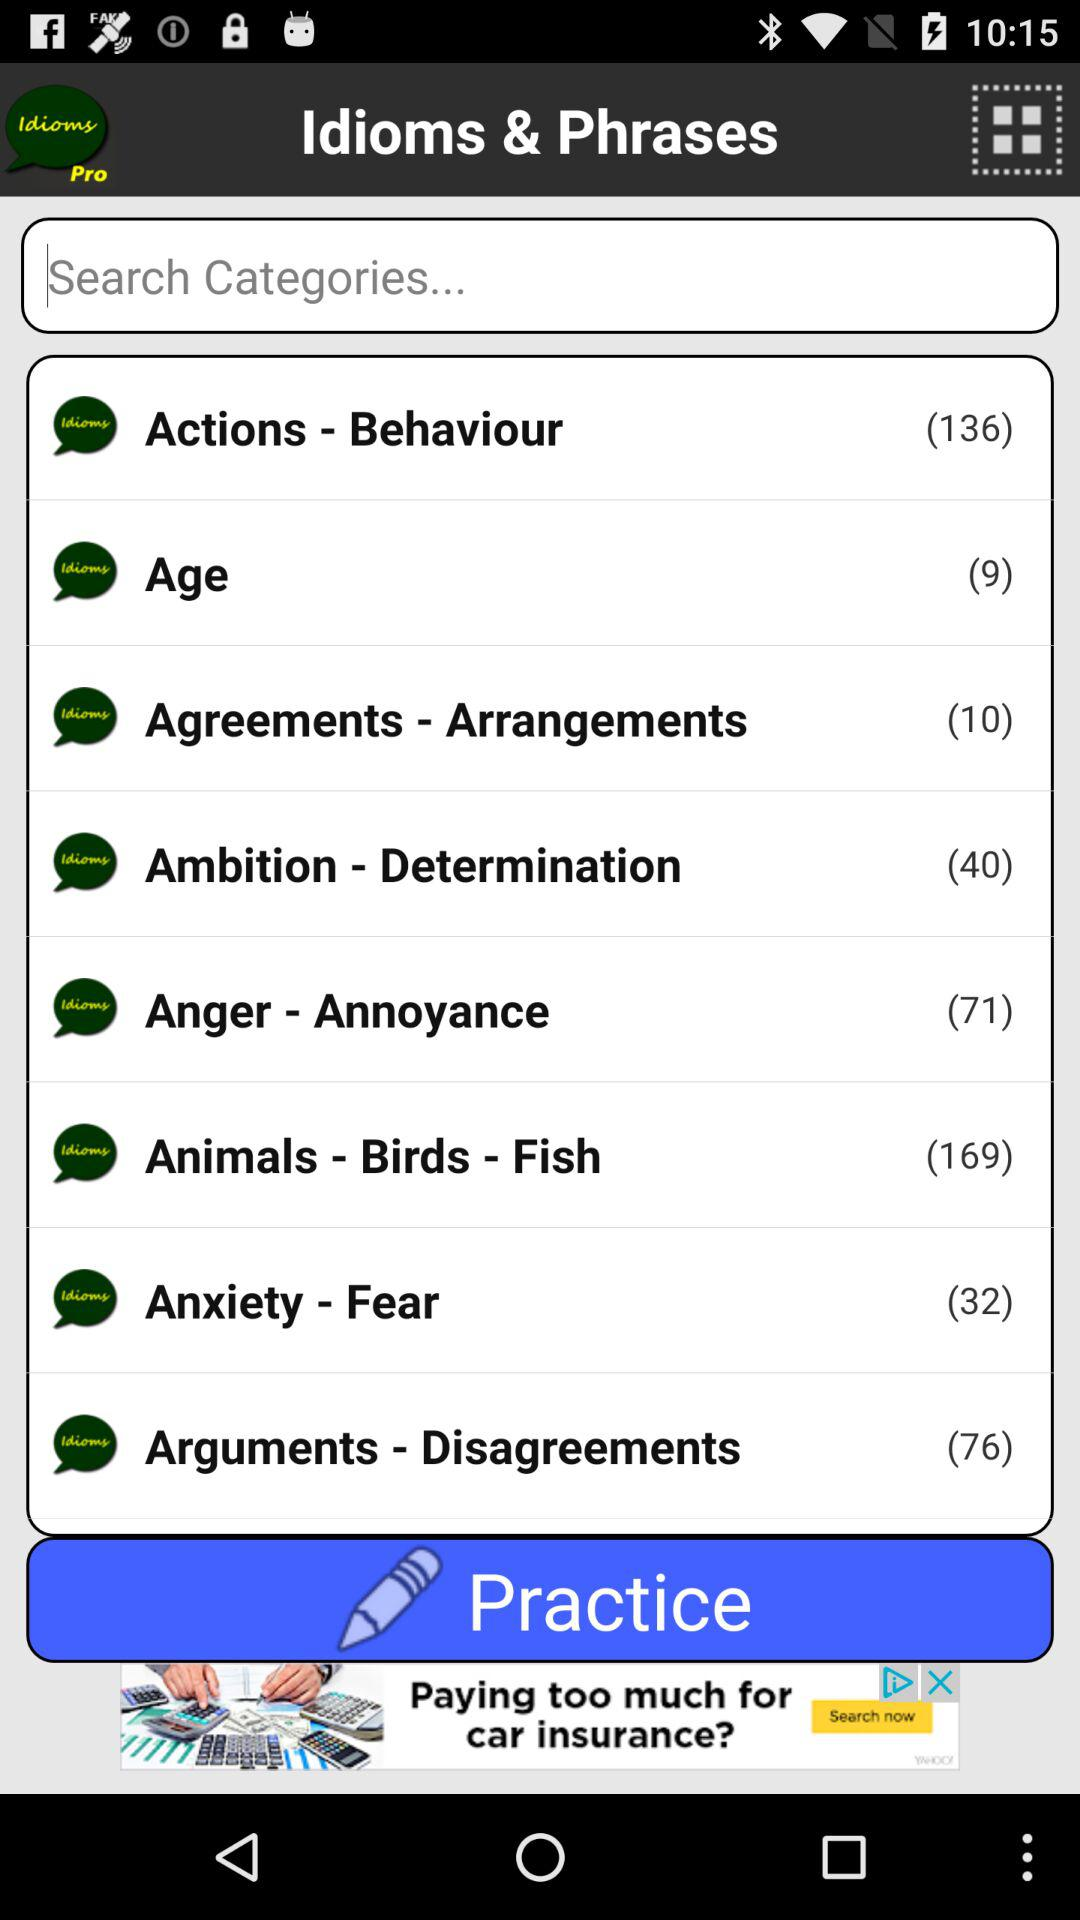How many idioms and phrases are there in "Ambition - Determination" category? There are 40 idioms and phrases. 